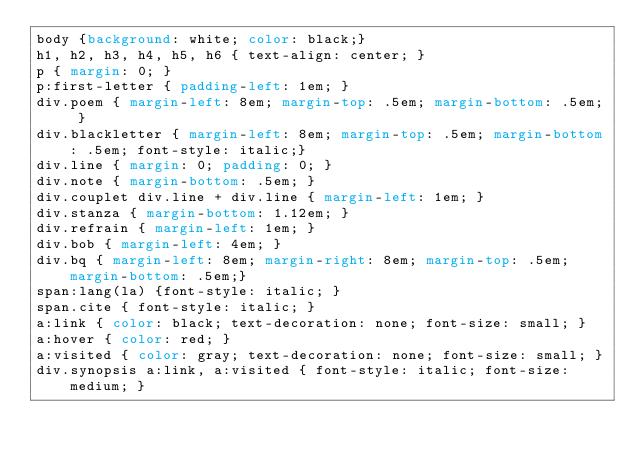<code> <loc_0><loc_0><loc_500><loc_500><_CSS_>body {background: white; color: black;}
h1, h2, h3, h4, h5, h6 { text-align: center; }
p { margin: 0; }
p:first-letter { padding-left: 1em; }
div.poem { margin-left: 8em; margin-top: .5em; margin-bottom: .5em; }
div.blackletter { margin-left: 8em; margin-top: .5em; margin-bottom: .5em; font-style: italic;}
div.line { margin: 0; padding: 0; }
div.note { margin-bottom: .5em; }
div.couplet div.line + div.line { margin-left: 1em; }
div.stanza { margin-bottom: 1.12em; }
div.refrain { margin-left: 1em; }
div.bob { margin-left: 4em; }
div.bq { margin-left: 8em; margin-right: 8em; margin-top: .5em; margin-bottom: .5em;}
span:lang(la) {font-style: italic; }
span.cite { font-style: italic; }
a:link { color: black; text-decoration: none; font-size: small; }
a:hover { color: red; }
a:visited { color: gray; text-decoration: none; font-size: small; }
div.synopsis a:link, a:visited { font-style: italic; font-size: medium; }
</code> 